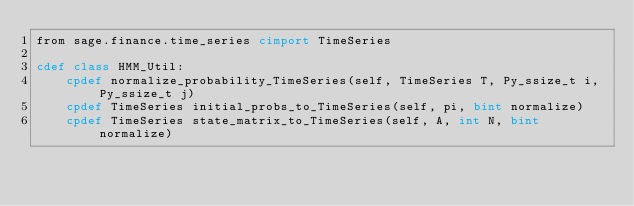<code> <loc_0><loc_0><loc_500><loc_500><_Cython_>from sage.finance.time_series cimport TimeSeries

cdef class HMM_Util:
    cpdef normalize_probability_TimeSeries(self, TimeSeries T, Py_ssize_t i, Py_ssize_t j)
    cpdef TimeSeries initial_probs_to_TimeSeries(self, pi, bint normalize)
    cpdef TimeSeries state_matrix_to_TimeSeries(self, A, int N, bint normalize)

</code> 